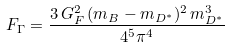<formula> <loc_0><loc_0><loc_500><loc_500>F _ { \Gamma } = \frac { 3 \, G _ { F } ^ { 2 } \, ( m _ { B } - m _ { D ^ { * } } ) ^ { 2 } \, m _ { D ^ { * } } ^ { 3 } } { 4 ^ { 5 } \pi ^ { 4 } }</formula> 